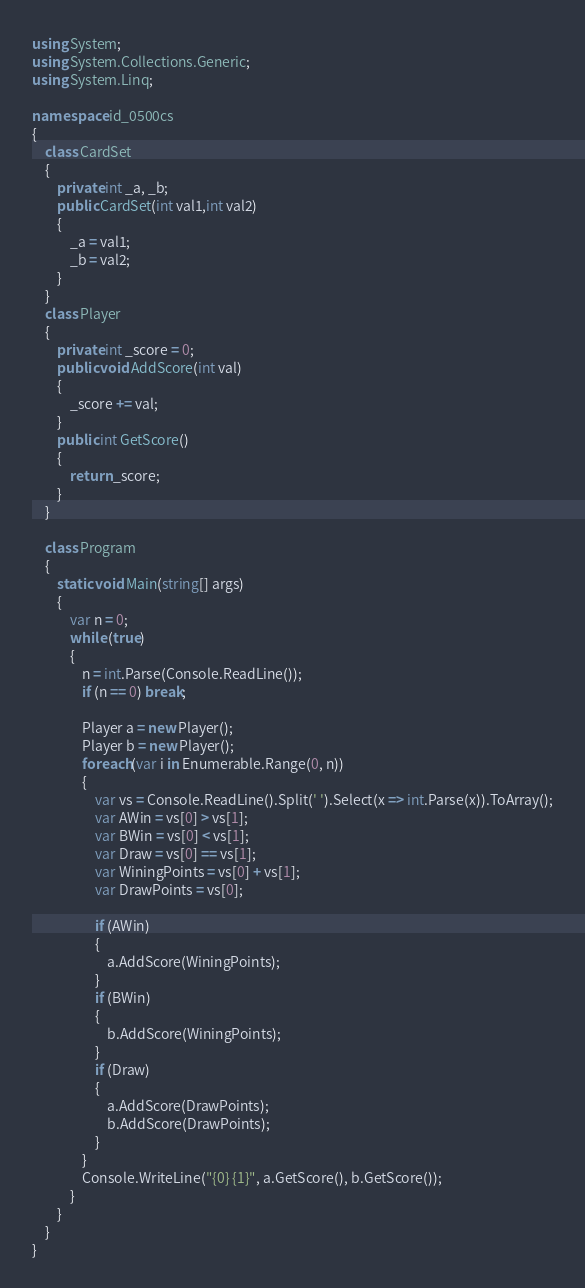Convert code to text. <code><loc_0><loc_0><loc_500><loc_500><_C#_>using System;
using System.Collections.Generic;
using System.Linq;

namespace id_0500cs
{
    class CardSet
    {
        private int _a, _b;
        public CardSet(int val1,int val2)
        {
            _a = val1;
            _b = val2;
        }
    }
    class Player
    {
        private int _score = 0;
        public void AddScore(int val)
        {
            _score += val;
        }
        public int GetScore()
        {
            return _score;
        }
    }

    class Program
    {
        static void Main(string[] args)
        {
            var n = 0;
            while (true)
            {
                n = int.Parse(Console.ReadLine());
                if (n == 0) break;

                Player a = new Player();
                Player b = new Player();
                foreach(var i in Enumerable.Range(0, n))
                {
                    var vs = Console.ReadLine().Split(' ').Select(x => int.Parse(x)).ToArray();
                    var AWin = vs[0] > vs[1];
                    var BWin = vs[0] < vs[1];
                    var Draw = vs[0] == vs[1];
                    var WiningPoints = vs[0] + vs[1];
                    var DrawPoints = vs[0];

                    if (AWin)
                    {
                        a.AddScore(WiningPoints);
                    }
                    if (BWin)
                    {
                        b.AddScore(WiningPoints);
                    }
                    if (Draw)
                    {
                        a.AddScore(DrawPoints);
                        b.AddScore(DrawPoints);
                    }
                }
                Console.WriteLine("{0} {1}", a.GetScore(), b.GetScore());
            }
        }
    }
}

</code> 